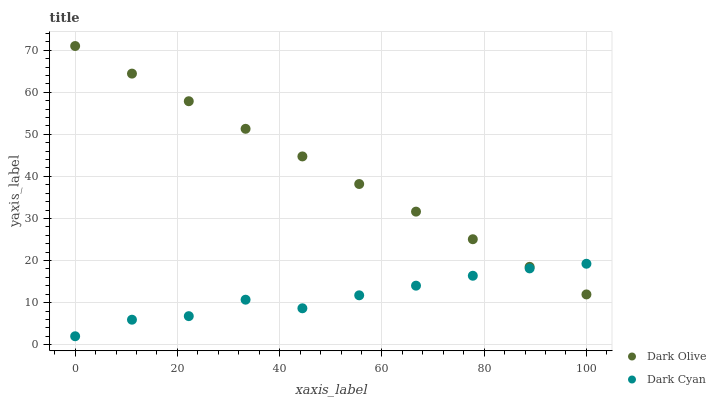Does Dark Cyan have the minimum area under the curve?
Answer yes or no. Yes. Does Dark Olive have the maximum area under the curve?
Answer yes or no. Yes. Does Dark Olive have the minimum area under the curve?
Answer yes or no. No. Is Dark Olive the smoothest?
Answer yes or no. Yes. Is Dark Cyan the roughest?
Answer yes or no. Yes. Is Dark Olive the roughest?
Answer yes or no. No. Does Dark Cyan have the lowest value?
Answer yes or no. Yes. Does Dark Olive have the lowest value?
Answer yes or no. No. Does Dark Olive have the highest value?
Answer yes or no. Yes. Does Dark Olive intersect Dark Cyan?
Answer yes or no. Yes. Is Dark Olive less than Dark Cyan?
Answer yes or no. No. Is Dark Olive greater than Dark Cyan?
Answer yes or no. No. 